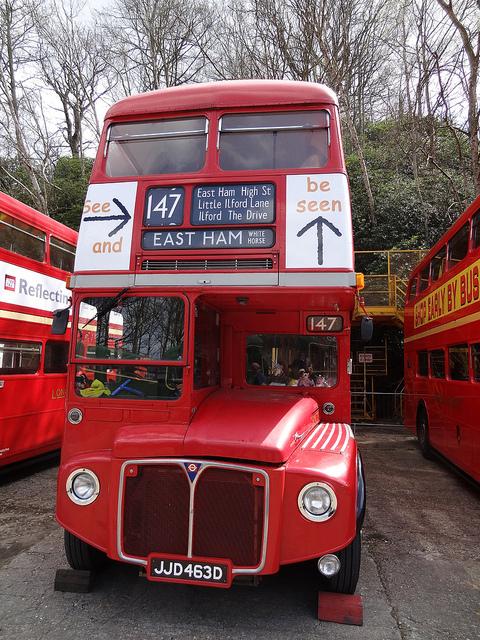Where is this bus going?
Write a very short answer. East ham. What color is the bus?
Short answer required. Red. What is under the tires?
Short answer required. Bricks. 